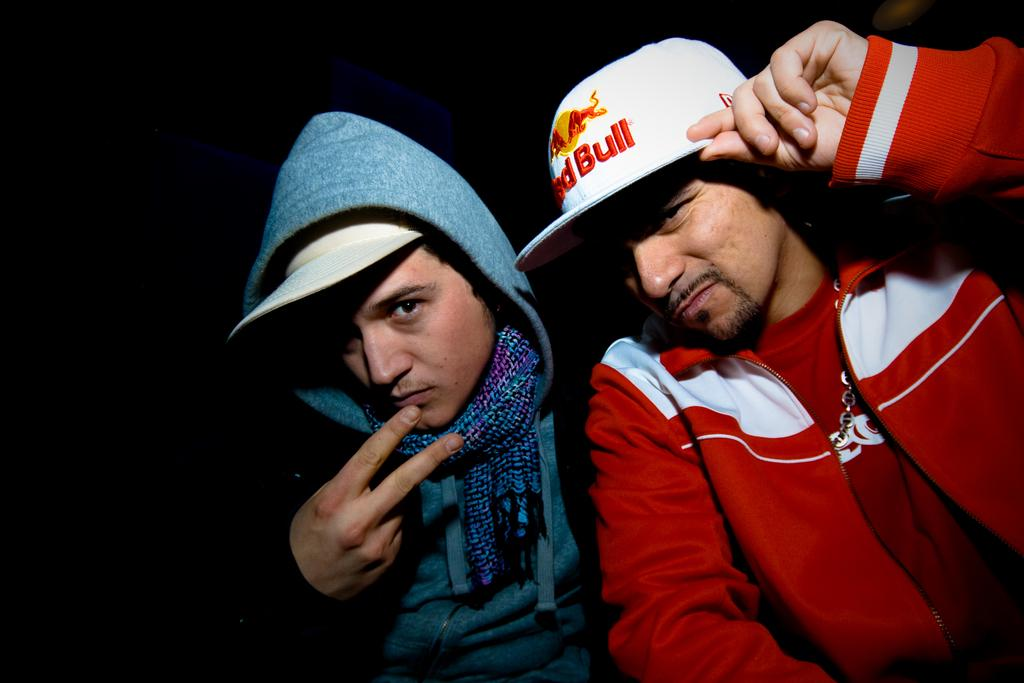<image>
Provide a brief description of the given image. Two men in caps, one of which has the word Bull visible on it. 